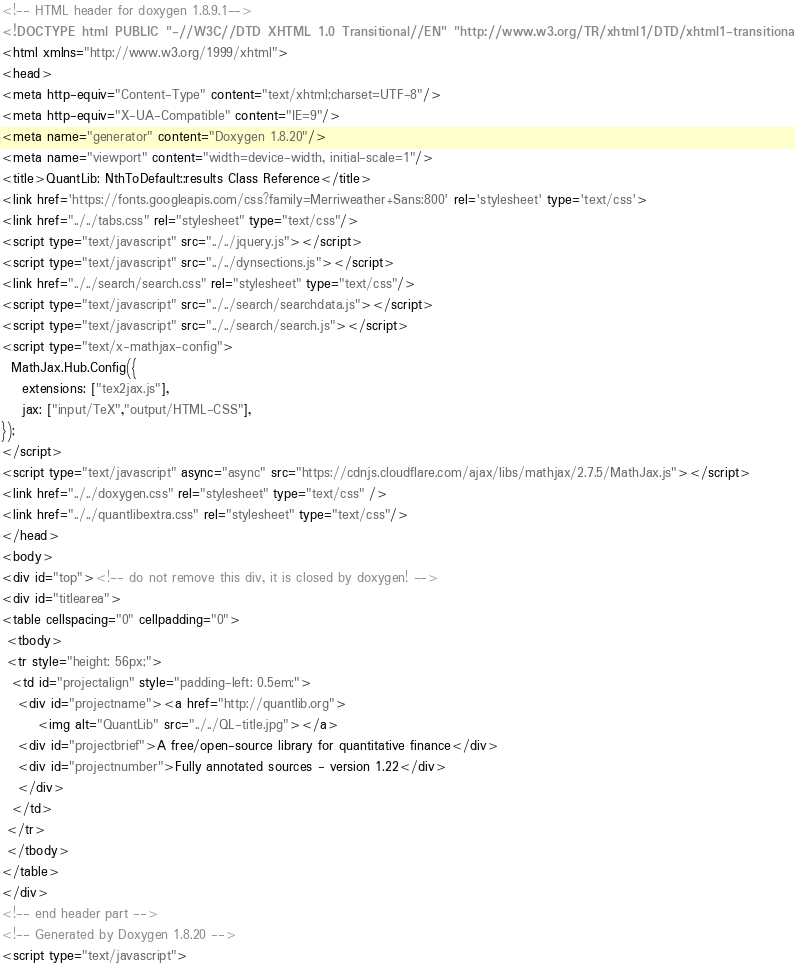Convert code to text. <code><loc_0><loc_0><loc_500><loc_500><_HTML_><!-- HTML header for doxygen 1.8.9.1-->
<!DOCTYPE html PUBLIC "-//W3C//DTD XHTML 1.0 Transitional//EN" "http://www.w3.org/TR/xhtml1/DTD/xhtml1-transitional.dtd">
<html xmlns="http://www.w3.org/1999/xhtml">
<head>
<meta http-equiv="Content-Type" content="text/xhtml;charset=UTF-8"/>
<meta http-equiv="X-UA-Compatible" content="IE=9"/>
<meta name="generator" content="Doxygen 1.8.20"/>
<meta name="viewport" content="width=device-width, initial-scale=1"/>
<title>QuantLib: NthToDefault::results Class Reference</title>
<link href='https://fonts.googleapis.com/css?family=Merriweather+Sans:800' rel='stylesheet' type='text/css'>
<link href="../../tabs.css" rel="stylesheet" type="text/css"/>
<script type="text/javascript" src="../../jquery.js"></script>
<script type="text/javascript" src="../../dynsections.js"></script>
<link href="../../search/search.css" rel="stylesheet" type="text/css"/>
<script type="text/javascript" src="../../search/searchdata.js"></script>
<script type="text/javascript" src="../../search/search.js"></script>
<script type="text/x-mathjax-config">
  MathJax.Hub.Config({
    extensions: ["tex2jax.js"],
    jax: ["input/TeX","output/HTML-CSS"],
});
</script>
<script type="text/javascript" async="async" src="https://cdnjs.cloudflare.com/ajax/libs/mathjax/2.7.5/MathJax.js"></script>
<link href="../../doxygen.css" rel="stylesheet" type="text/css" />
<link href="../../quantlibextra.css" rel="stylesheet" type="text/css"/>
</head>
<body>
<div id="top"><!-- do not remove this div, it is closed by doxygen! -->
<div id="titlearea">
<table cellspacing="0" cellpadding="0">
 <tbody>
 <tr style="height: 56px;">
  <td id="projectalign" style="padding-left: 0.5em;">
   <div id="projectname"><a href="http://quantlib.org">
       <img alt="QuantLib" src="../../QL-title.jpg"></a>
   <div id="projectbrief">A free/open-source library for quantitative finance</div>
   <div id="projectnumber">Fully annotated sources - version 1.22</div>
   </div>
  </td>
 </tr>
 </tbody>
</table>
</div>
<!-- end header part -->
<!-- Generated by Doxygen 1.8.20 -->
<script type="text/javascript"></code> 